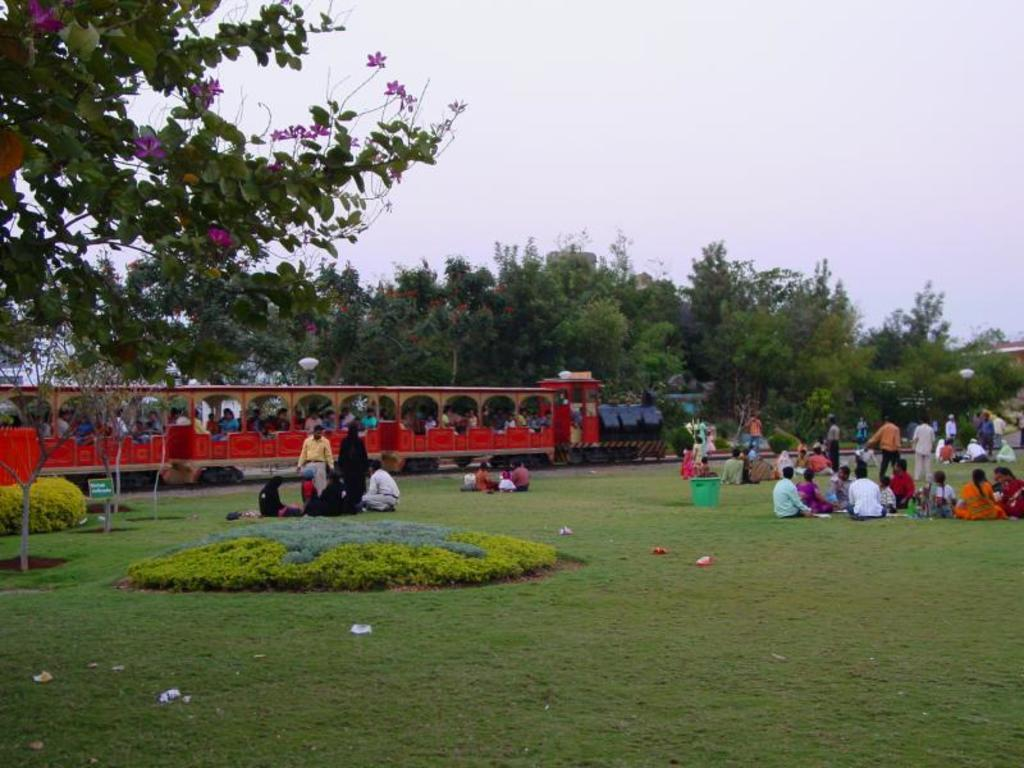How many people are in the image? There are many people in the image. What are the people doing in the image? The people are standing and sitting on the grassland. What can be seen in the background of the image? There is a train in the background of the image, and trees and the sky are visible above the train. What type of grape is being used to cause a disturbance among the people in the image? There is no grape present in the image, nor is there any indication of a disturbance among the people. 